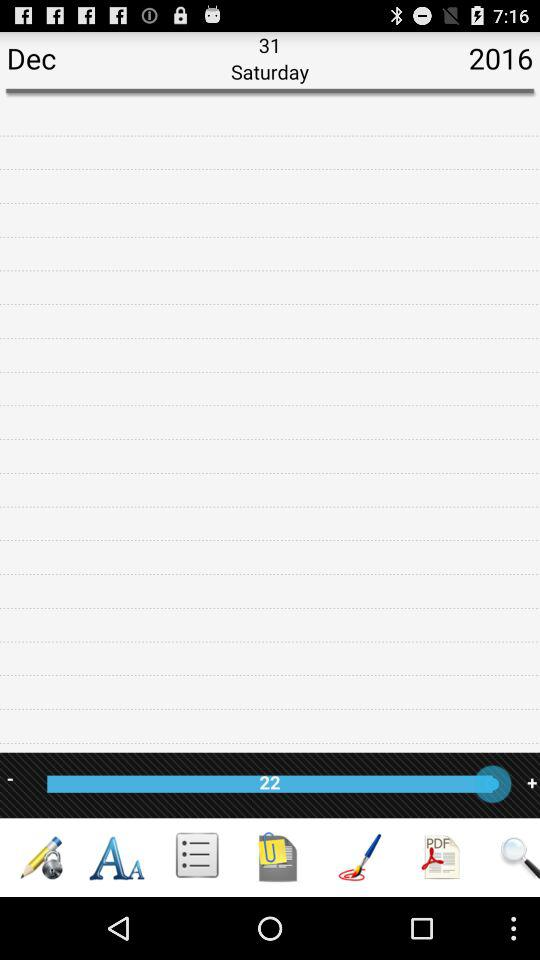What is the date? The date is Saturday, December 31, 2016. 